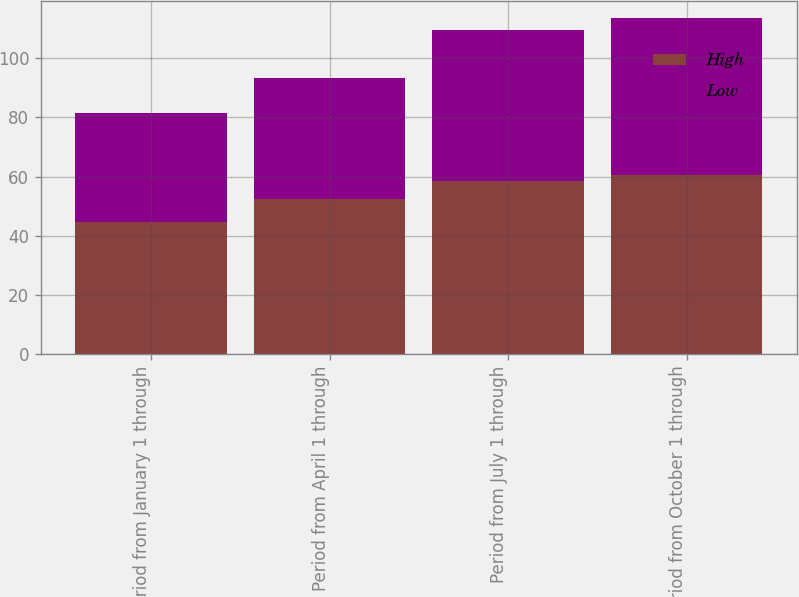<chart> <loc_0><loc_0><loc_500><loc_500><stacked_bar_chart><ecel><fcel>Period from January 1 through<fcel>Period from April 1 through<fcel>Period from July 1 through<fcel>Period from October 1 through<nl><fcel>High<fcel>44.65<fcel>52.46<fcel>58.6<fcel>60.42<nl><fcel>Low<fcel>37<fcel>40.78<fcel>51.12<fcel>53.4<nl></chart> 